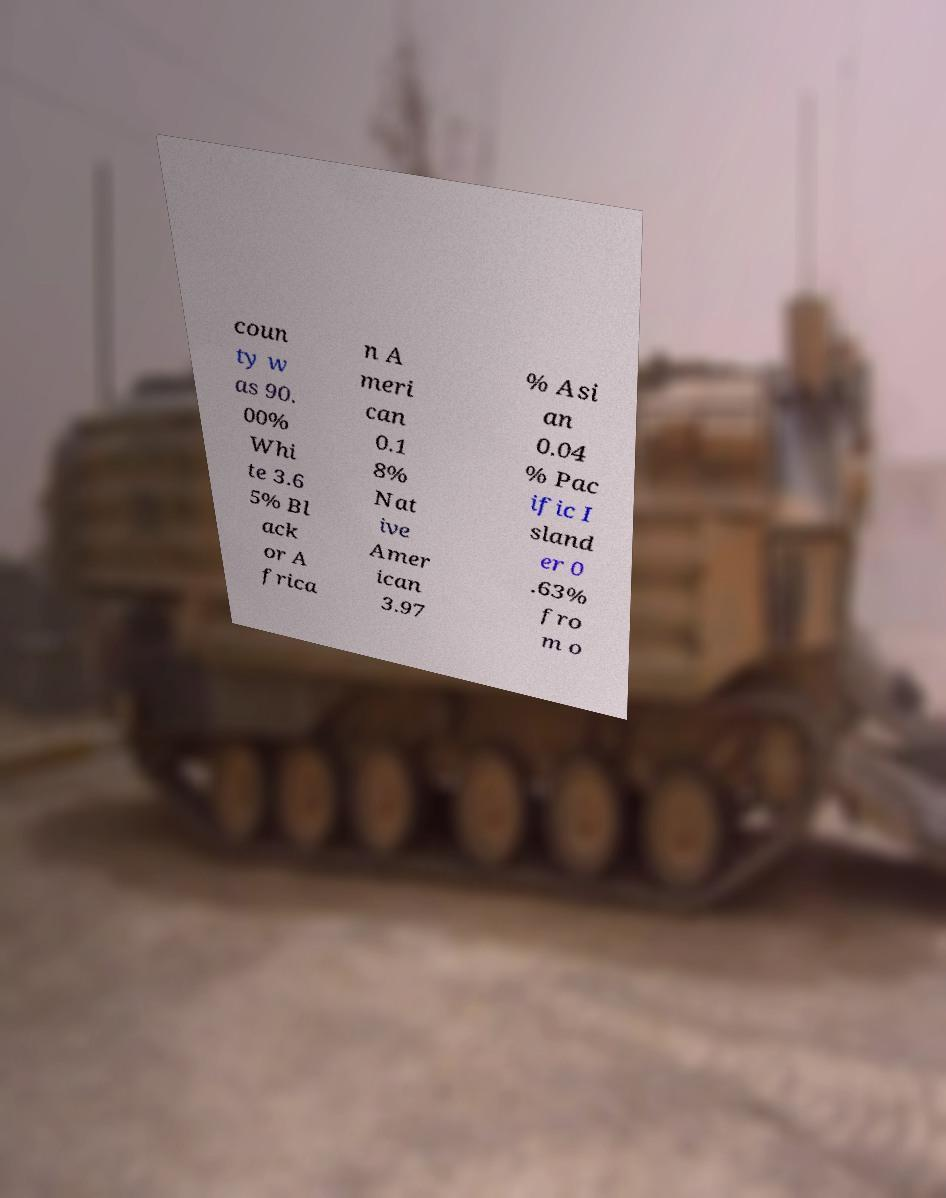I need the written content from this picture converted into text. Can you do that? coun ty w as 90. 00% Whi te 3.6 5% Bl ack or A frica n A meri can 0.1 8% Nat ive Amer ican 3.97 % Asi an 0.04 % Pac ific I sland er 0 .63% fro m o 